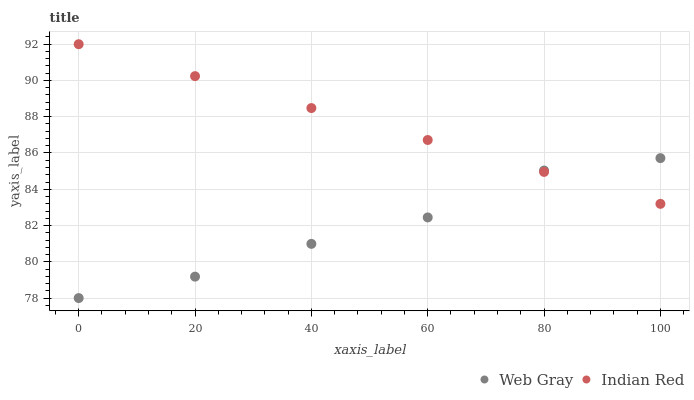Does Web Gray have the minimum area under the curve?
Answer yes or no. Yes. Does Indian Red have the maximum area under the curve?
Answer yes or no. Yes. Does Indian Red have the minimum area under the curve?
Answer yes or no. No. Is Indian Red the smoothest?
Answer yes or no. Yes. Is Web Gray the roughest?
Answer yes or no. Yes. Is Indian Red the roughest?
Answer yes or no. No. Does Web Gray have the lowest value?
Answer yes or no. Yes. Does Indian Red have the lowest value?
Answer yes or no. No. Does Indian Red have the highest value?
Answer yes or no. Yes. Does Web Gray intersect Indian Red?
Answer yes or no. Yes. Is Web Gray less than Indian Red?
Answer yes or no. No. Is Web Gray greater than Indian Red?
Answer yes or no. No. 